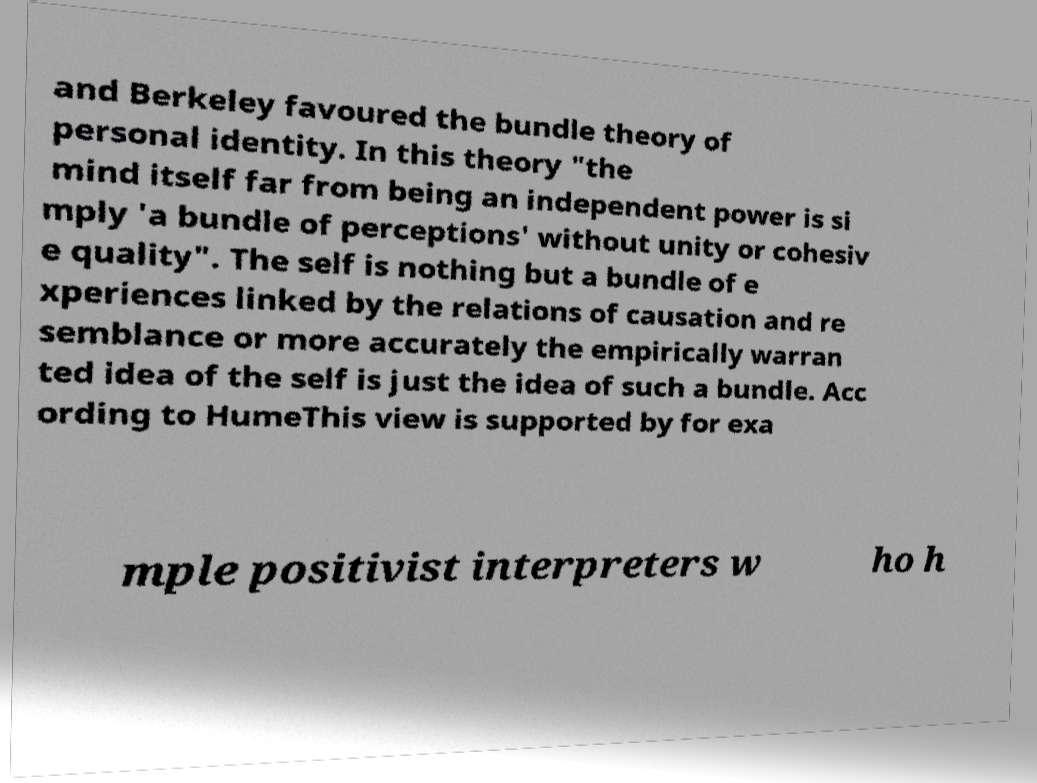Could you assist in decoding the text presented in this image and type it out clearly? and Berkeley favoured the bundle theory of personal identity. In this theory "the mind itself far from being an independent power is si mply 'a bundle of perceptions' without unity or cohesiv e quality". The self is nothing but a bundle of e xperiences linked by the relations of causation and re semblance or more accurately the empirically warran ted idea of the self is just the idea of such a bundle. Acc ording to HumeThis view is supported by for exa mple positivist interpreters w ho h 